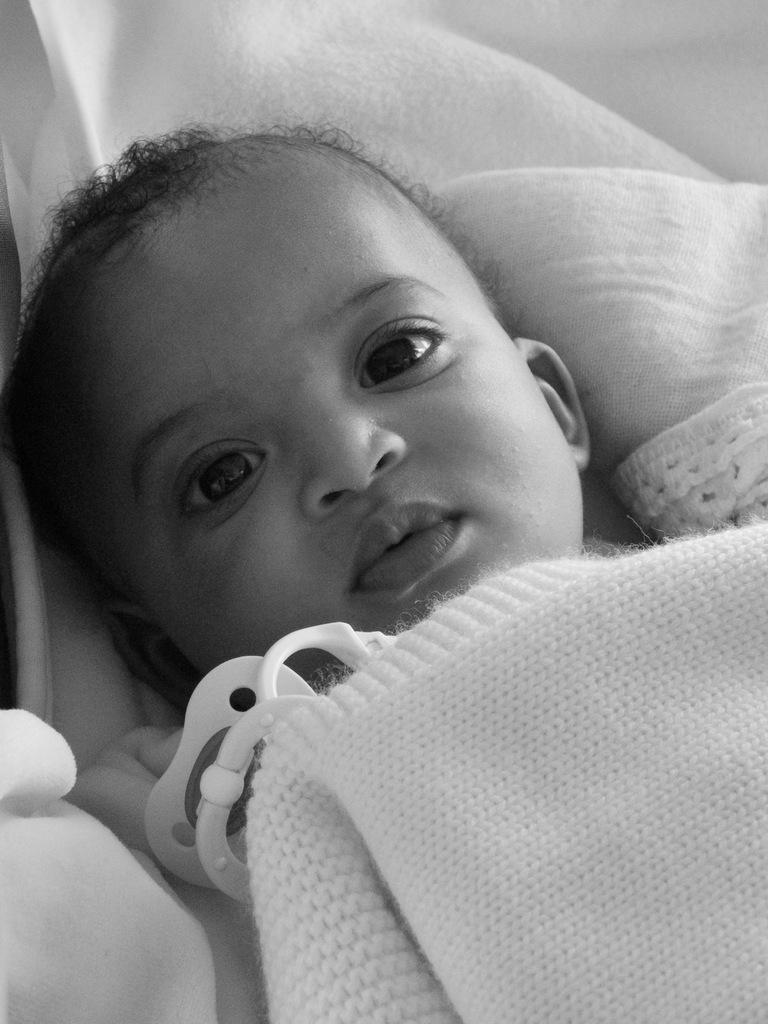What is the main subject of the image? There is a baby in the center of the image. Where is the baby located? The baby is lying on a bed. What is at the bottom of the image? There is a blanket at the bottom of the image. What type of celery can be seen growing on the wall in the image? There is no celery or wall present in the image; it features a baby lying on a bed with a blanket at the bottom. 